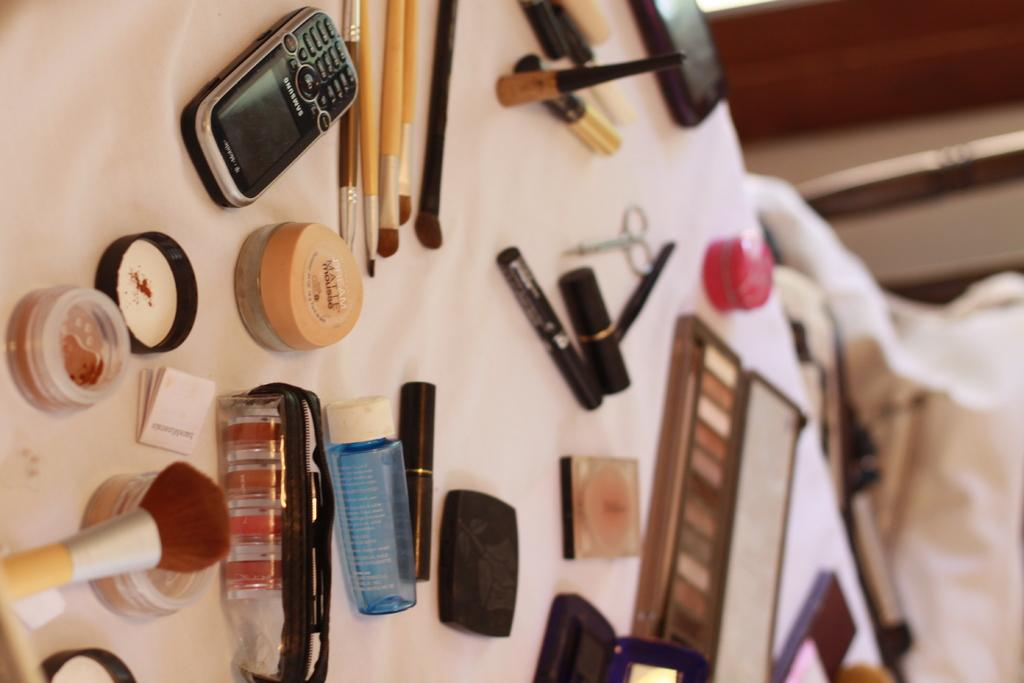<image>
Render a clear and concise summary of the photo. A Samsung phone lays on a bed surrounded by make up products like brushes, mascara and eye shadow. 